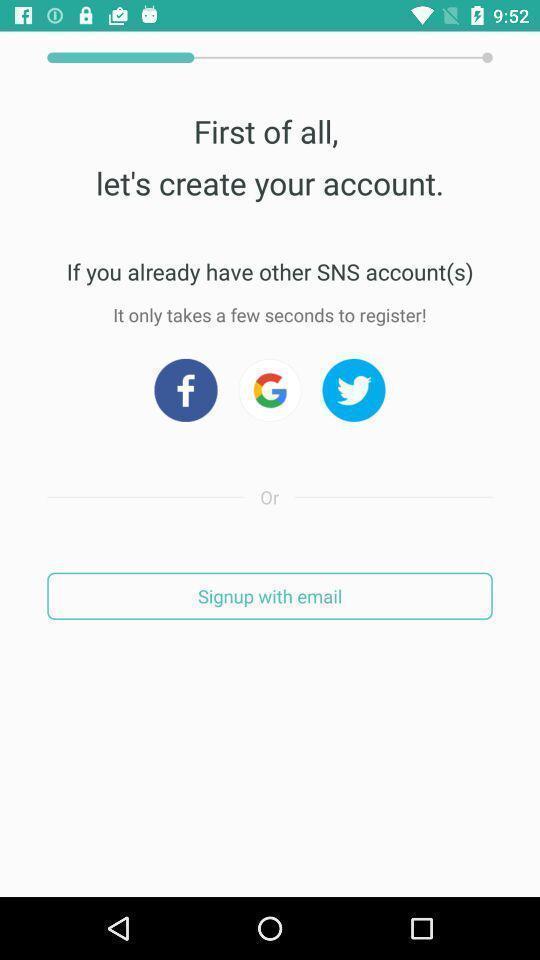Provide a textual representation of this image. Sign up page of a social app. 